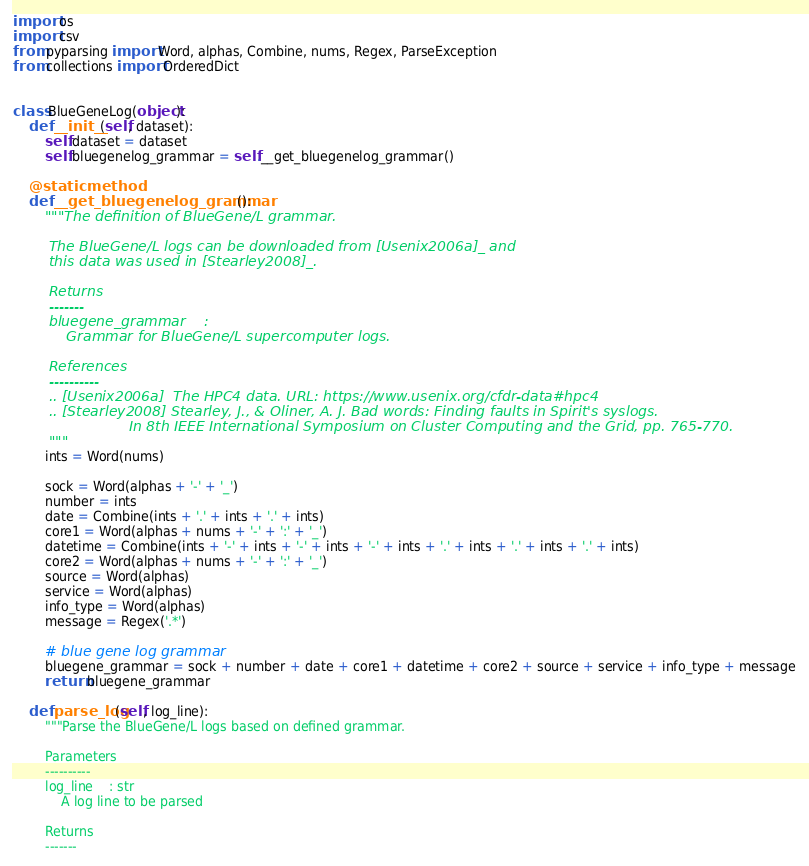<code> <loc_0><loc_0><loc_500><loc_500><_Python_>import os
import csv
from pyparsing import Word, alphas, Combine, nums, Regex, ParseException
from collections import OrderedDict


class BlueGeneLog(object):
    def __init__(self, dataset):
        self.dataset = dataset
        self.bluegenelog_grammar = self.__get_bluegenelog_grammar()

    @staticmethod
    def __get_bluegenelog_grammar():
        """The definition of BlueGene/L grammar.

        The BlueGene/L logs can be downloaded from [Usenix2006a]_ and
        this data was used in [Stearley2008]_.

        Returns
        -------
        bluegene_grammar    :
            Grammar for BlueGene/L supercomputer logs.

        References
        ----------
        .. [Usenix2006a]  The HPC4 data. URL: https://www.usenix.org/cfdr-data#hpc4
        .. [Stearley2008] Stearley, J., & Oliner, A. J. Bad words: Finding faults in Spirit's syslogs.
                          In 8th IEEE International Symposium on Cluster Computing and the Grid, pp. 765-770.
        """
        ints = Word(nums)

        sock = Word(alphas + '-' + '_')
        number = ints
        date = Combine(ints + '.' + ints + '.' + ints)
        core1 = Word(alphas + nums + '-' + ':' + '_')
        datetime = Combine(ints + '-' + ints + '-' + ints + '-' + ints + '.' + ints + '.' + ints + '.' + ints)
        core2 = Word(alphas + nums + '-' + ':' + '_')
        source = Word(alphas)
        service = Word(alphas)
        info_type = Word(alphas)
        message = Regex('.*')

        # blue gene log grammar
        bluegene_grammar = sock + number + date + core1 + datetime + core2 + source + service + info_type + message
        return bluegene_grammar

    def parse_log(self, log_line):
        """Parse the BlueGene/L logs based on defined grammar.

        Parameters
        ----------
        log_line    : str
            A log line to be parsed

        Returns
        -------</code> 